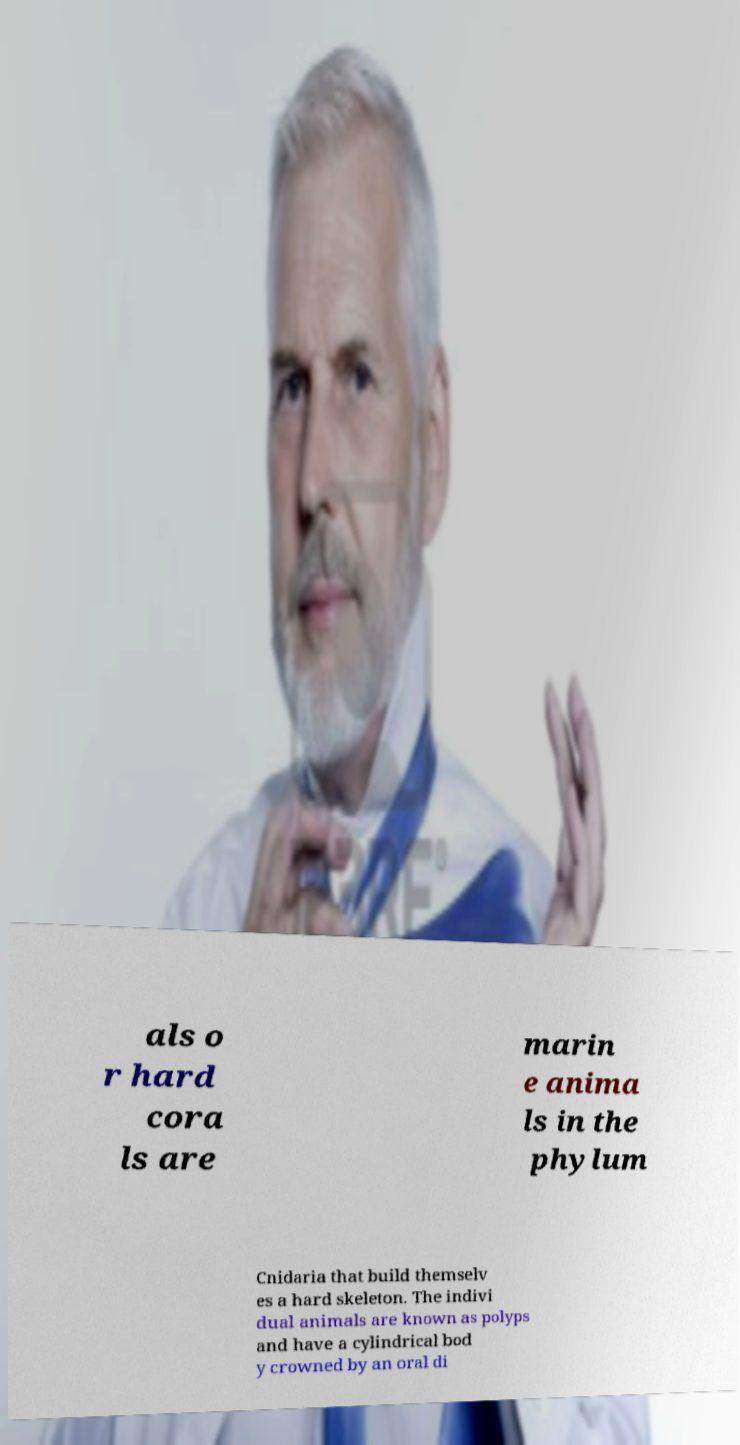I need the written content from this picture converted into text. Can you do that? als o r hard cora ls are marin e anima ls in the phylum Cnidaria that build themselv es a hard skeleton. The indivi dual animals are known as polyps and have a cylindrical bod y crowned by an oral di 